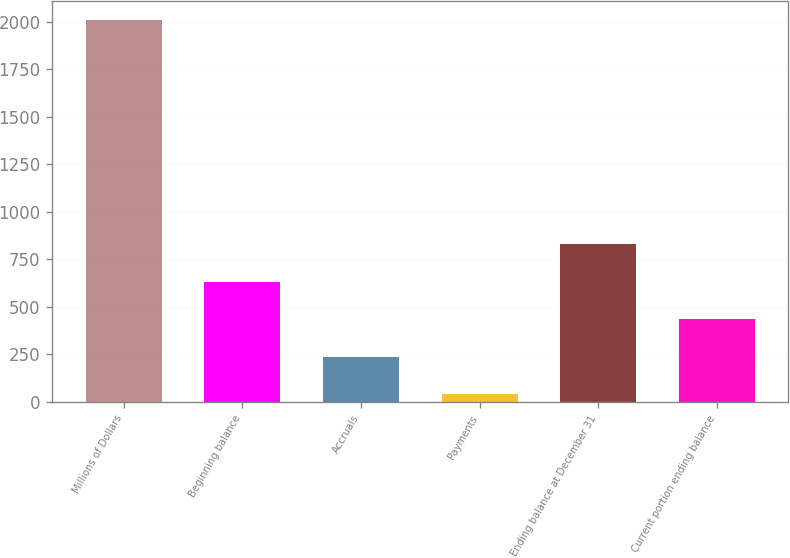Convert chart. <chart><loc_0><loc_0><loc_500><loc_500><bar_chart><fcel>Millions of Dollars<fcel>Beginning balance<fcel>Accruals<fcel>Payments<fcel>Ending balance at December 31<fcel>Current portion ending balance<nl><fcel>2009<fcel>631.4<fcel>237.8<fcel>41<fcel>828.2<fcel>434.6<nl></chart> 